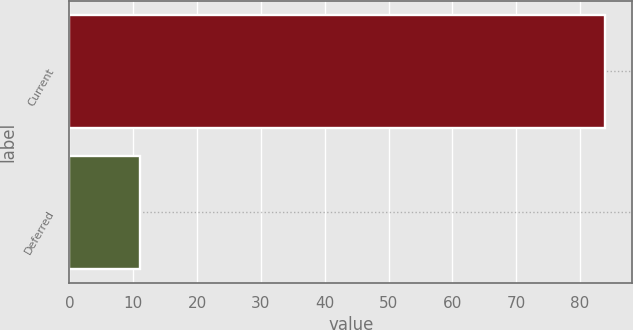<chart> <loc_0><loc_0><loc_500><loc_500><bar_chart><fcel>Current<fcel>Deferred<nl><fcel>84<fcel>11<nl></chart> 